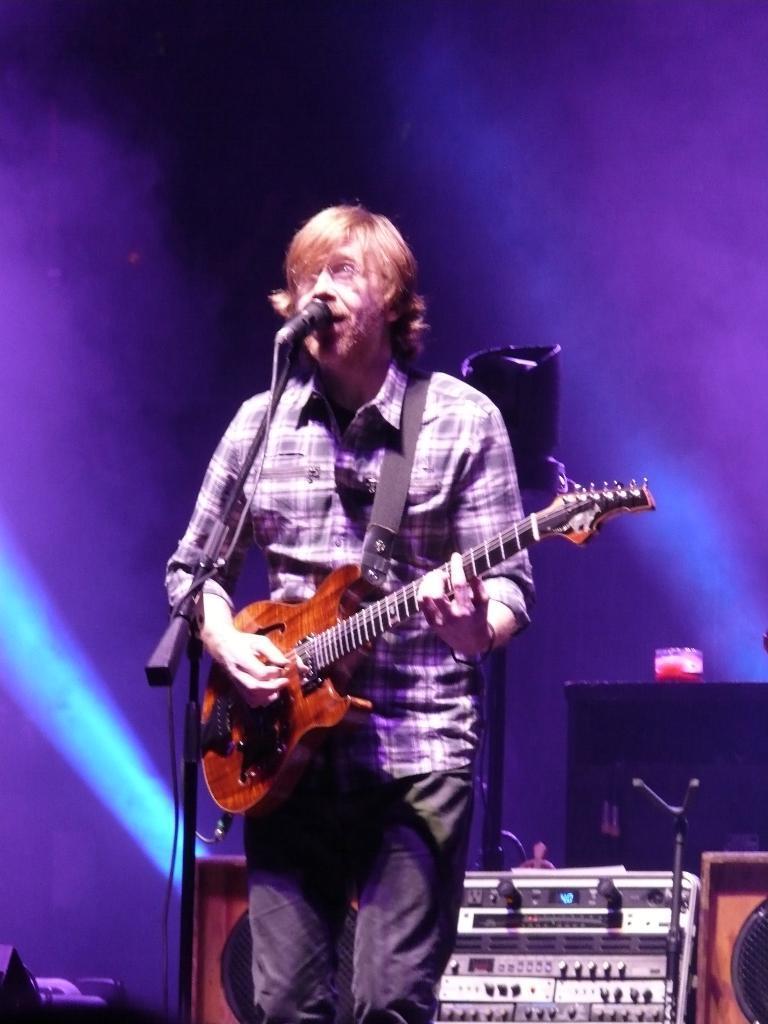Describe this image in one or two sentences. In this we can see a man standing, and singing and holding a guitar in his hands, and here is the micro phone and stand, and at back there are some objects. 